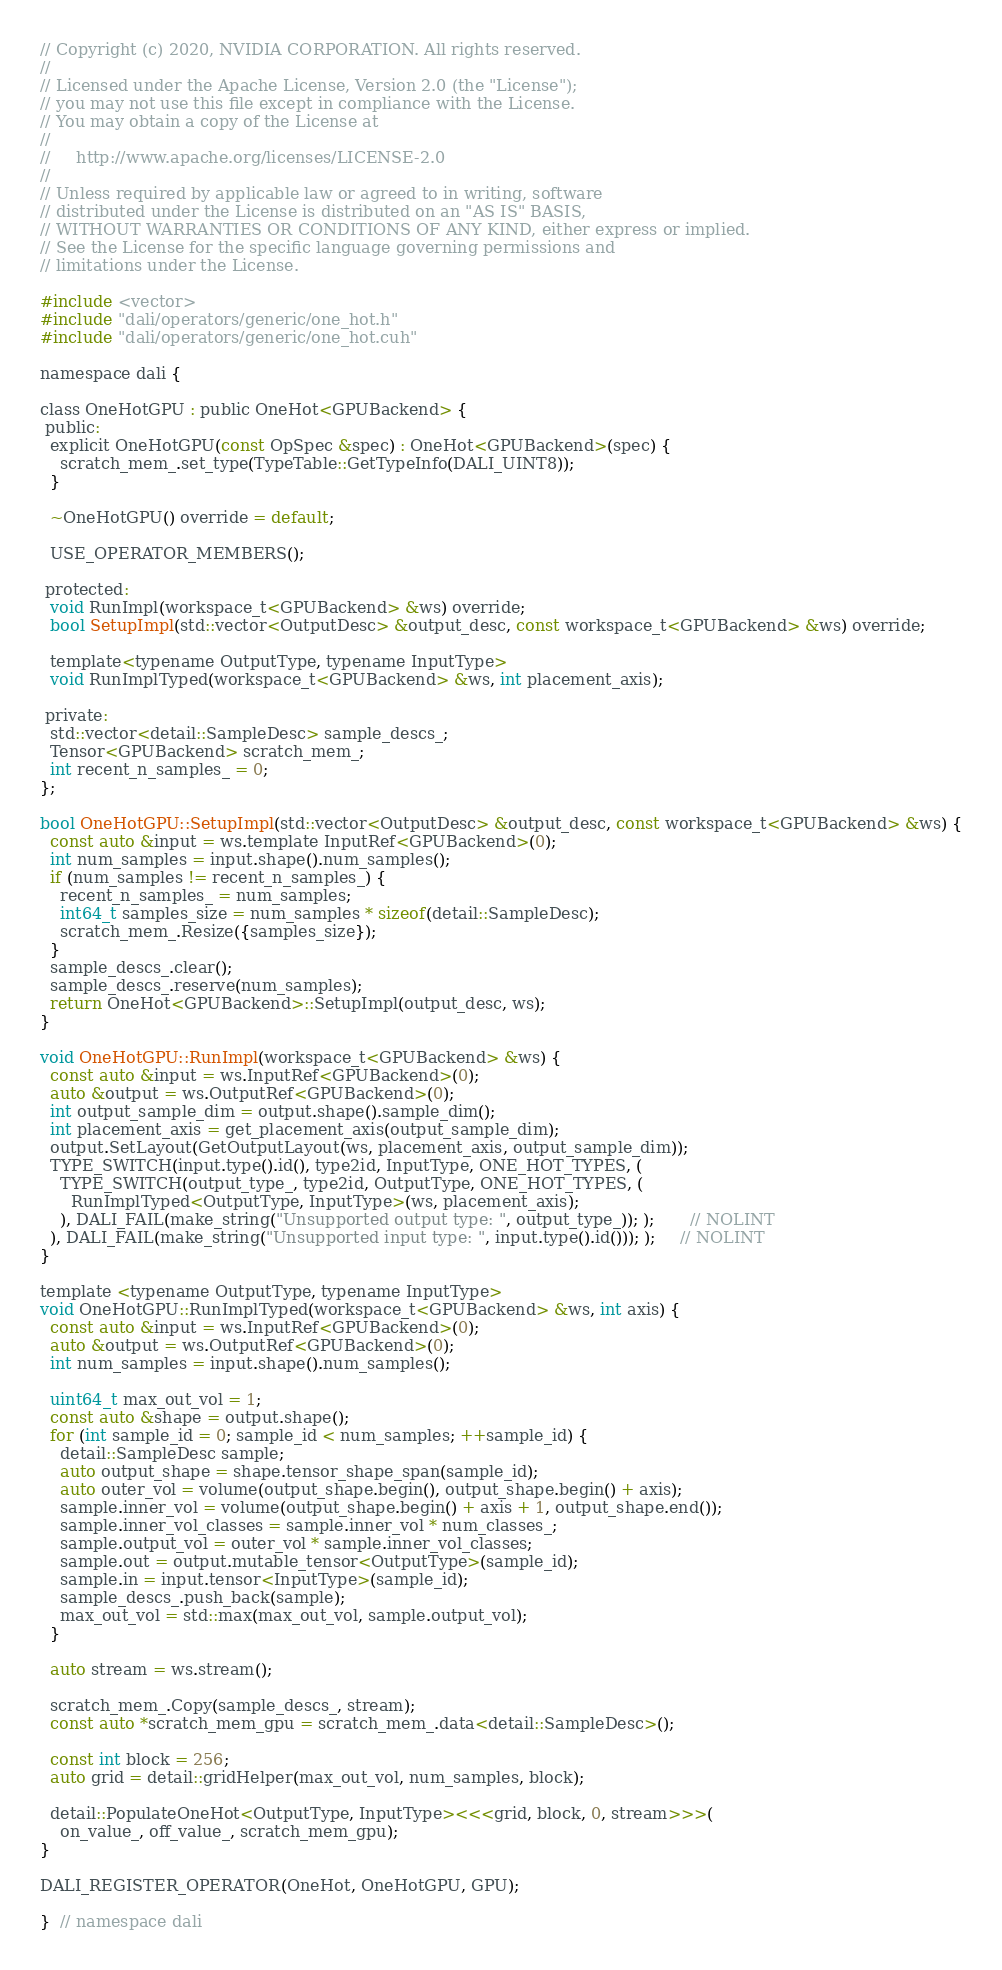Convert code to text. <code><loc_0><loc_0><loc_500><loc_500><_Cuda_>// Copyright (c) 2020, NVIDIA CORPORATION. All rights reserved.
//
// Licensed under the Apache License, Version 2.0 (the "License");
// you may not use this file except in compliance with the License.
// You may obtain a copy of the License at
//
//     http://www.apache.org/licenses/LICENSE-2.0
//
// Unless required by applicable law or agreed to in writing, software
// distributed under the License is distributed on an "AS IS" BASIS,
// WITHOUT WARRANTIES OR CONDITIONS OF ANY KIND, either express or implied.
// See the License for the specific language governing permissions and
// limitations under the License.

#include <vector>
#include "dali/operators/generic/one_hot.h"
#include "dali/operators/generic/one_hot.cuh"

namespace dali {

class OneHotGPU : public OneHot<GPUBackend> {
 public:
  explicit OneHotGPU(const OpSpec &spec) : OneHot<GPUBackend>(spec) {
    scratch_mem_.set_type(TypeTable::GetTypeInfo(DALI_UINT8));
  }

  ~OneHotGPU() override = default;

  USE_OPERATOR_MEMBERS();

 protected:
  void RunImpl(workspace_t<GPUBackend> &ws) override;
  bool SetupImpl(std::vector<OutputDesc> &output_desc, const workspace_t<GPUBackend> &ws) override;

  template<typename OutputType, typename InputType>
  void RunImplTyped(workspace_t<GPUBackend> &ws, int placement_axis);

 private:
  std::vector<detail::SampleDesc> sample_descs_;
  Tensor<GPUBackend> scratch_mem_;
  int recent_n_samples_ = 0;
};

bool OneHotGPU::SetupImpl(std::vector<OutputDesc> &output_desc, const workspace_t<GPUBackend> &ws) {
  const auto &input = ws.template InputRef<GPUBackend>(0);
  int num_samples = input.shape().num_samples();
  if (num_samples != recent_n_samples_) {
    recent_n_samples_ = num_samples;
    int64_t samples_size = num_samples * sizeof(detail::SampleDesc);
    scratch_mem_.Resize({samples_size});
  }
  sample_descs_.clear();
  sample_descs_.reserve(num_samples);
  return OneHot<GPUBackend>::SetupImpl(output_desc, ws);
}

void OneHotGPU::RunImpl(workspace_t<GPUBackend> &ws) {
  const auto &input = ws.InputRef<GPUBackend>(0);
  auto &output = ws.OutputRef<GPUBackend>(0);
  int output_sample_dim = output.shape().sample_dim();
  int placement_axis = get_placement_axis(output_sample_dim);
  output.SetLayout(GetOutputLayout(ws, placement_axis, output_sample_dim));
  TYPE_SWITCH(input.type().id(), type2id, InputType, ONE_HOT_TYPES, (
    TYPE_SWITCH(output_type_, type2id, OutputType, ONE_HOT_TYPES, (
      RunImplTyped<OutputType, InputType>(ws, placement_axis);
    ), DALI_FAIL(make_string("Unsupported output type: ", output_type_)); );       // NOLINT
  ), DALI_FAIL(make_string("Unsupported input type: ", input.type().id())); );     // NOLINT
}

template <typename OutputType, typename InputType>
void OneHotGPU::RunImplTyped(workspace_t<GPUBackend> &ws, int axis) {
  const auto &input = ws.InputRef<GPUBackend>(0);
  auto &output = ws.OutputRef<GPUBackend>(0);
  int num_samples = input.shape().num_samples();

  uint64_t max_out_vol = 1;
  const auto &shape = output.shape();
  for (int sample_id = 0; sample_id < num_samples; ++sample_id) {
    detail::SampleDesc sample;
    auto output_shape = shape.tensor_shape_span(sample_id);
    auto outer_vol = volume(output_shape.begin(), output_shape.begin() + axis);
    sample.inner_vol = volume(output_shape.begin() + axis + 1, output_shape.end());
    sample.inner_vol_classes = sample.inner_vol * num_classes_;
    sample.output_vol = outer_vol * sample.inner_vol_classes;
    sample.out = output.mutable_tensor<OutputType>(sample_id);
    sample.in = input.tensor<InputType>(sample_id);
    sample_descs_.push_back(sample);
    max_out_vol = std::max(max_out_vol, sample.output_vol);
  }

  auto stream = ws.stream();

  scratch_mem_.Copy(sample_descs_, stream);
  const auto *scratch_mem_gpu = scratch_mem_.data<detail::SampleDesc>();

  const int block = 256;
  auto grid = detail::gridHelper(max_out_vol, num_samples, block);

  detail::PopulateOneHot<OutputType, InputType><<<grid, block, 0, stream>>>(
    on_value_, off_value_, scratch_mem_gpu);
}

DALI_REGISTER_OPERATOR(OneHot, OneHotGPU, GPU);

}  // namespace dali
</code> 